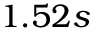<formula> <loc_0><loc_0><loc_500><loc_500>1 . 5 2 s</formula> 